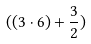<formula> <loc_0><loc_0><loc_500><loc_500>( ( 3 \cdot 6 ) + \frac { 3 } { 2 } )</formula> 